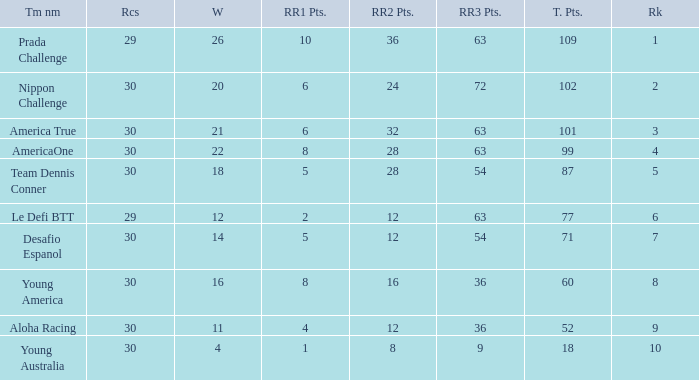Name the most rr1 pts for 7 ranking 5.0. 